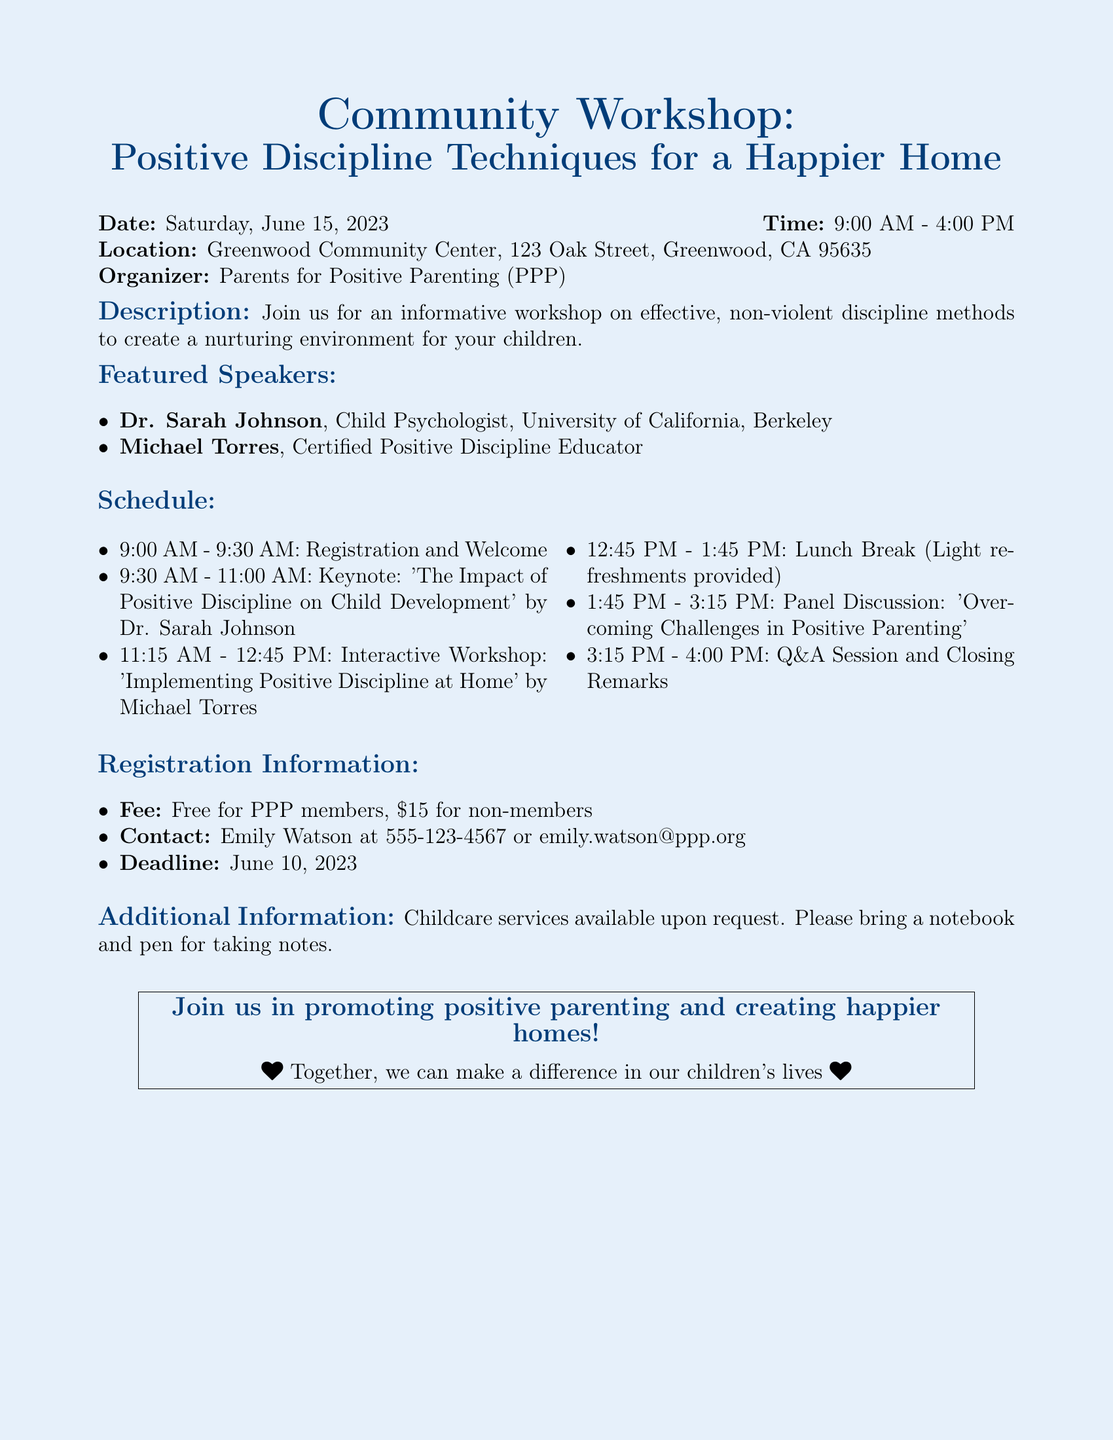What is the date of the workshop? The date of the workshop is clearly mentioned in the document, which is Saturday, June 15, 2023.
Answer: Saturday, June 15, 2023 Who is the organizer of the workshop? The document states that the workshop is organized by Parents for Positive Parenting (PPP).
Answer: Parents for Positive Parenting (PPP) What time does the workshop start? The starting time of the workshop is provided in the document, which is 9:00 AM.
Answer: 9:00 AM What is the fee for non-members? The document specifies the fee for non-members as $15.
Answer: $15 Who is the keynote speaker? The document lists Dr. Sarah Johnson as the keynote speaker of the workshop.
Answer: Dr. Sarah Johnson What will be discussed in the panel discussion? The document mentions the topic of the panel discussion as 'Overcoming Challenges in Positive Parenting.'
Answer: Overcoming Challenges in Positive Parenting Is childcare available at the workshop? The document indicates that childcare services are available upon request.
Answer: Yes What should participants bring for taking notes? The document suggests that participants should bring a notebook and pen for taking notes.
Answer: Notebook and pen 